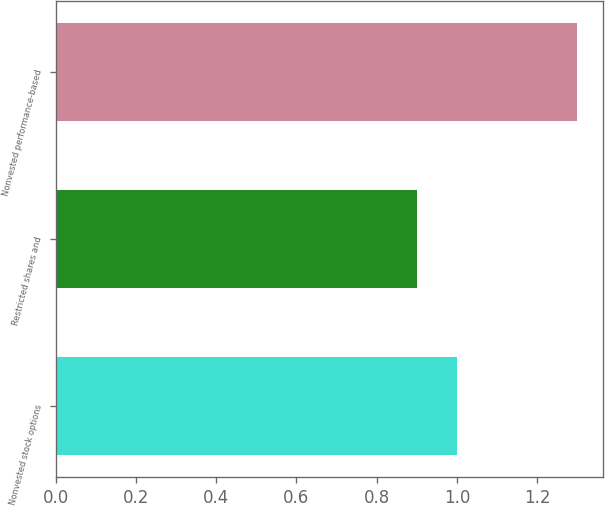Convert chart. <chart><loc_0><loc_0><loc_500><loc_500><bar_chart><fcel>Nonvested stock options<fcel>Restricted shares and<fcel>Nonvested performance-based<nl><fcel>1<fcel>0.9<fcel>1.3<nl></chart> 